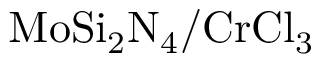<formula> <loc_0><loc_0><loc_500><loc_500>M o S i _ { 2 } N _ { 4 } / C r C l _ { 3 }</formula> 